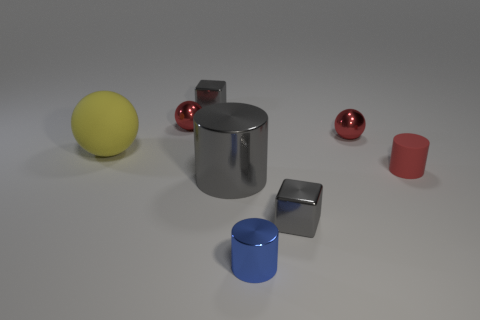Add 2 small red shiny objects. How many objects exist? 10 Subtract all cylinders. How many objects are left? 5 Subtract all big gray shiny cylinders. Subtract all big gray shiny cylinders. How many objects are left? 6 Add 6 gray metal objects. How many gray metal objects are left? 9 Add 3 tiny red rubber objects. How many tiny red rubber objects exist? 4 Subtract 0 purple cylinders. How many objects are left? 8 